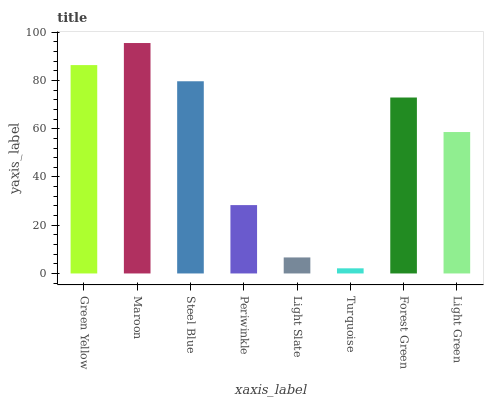Is Turquoise the minimum?
Answer yes or no. Yes. Is Maroon the maximum?
Answer yes or no. Yes. Is Steel Blue the minimum?
Answer yes or no. No. Is Steel Blue the maximum?
Answer yes or no. No. Is Maroon greater than Steel Blue?
Answer yes or no. Yes. Is Steel Blue less than Maroon?
Answer yes or no. Yes. Is Steel Blue greater than Maroon?
Answer yes or no. No. Is Maroon less than Steel Blue?
Answer yes or no. No. Is Forest Green the high median?
Answer yes or no. Yes. Is Light Green the low median?
Answer yes or no. Yes. Is Light Green the high median?
Answer yes or no. No. Is Turquoise the low median?
Answer yes or no. No. 